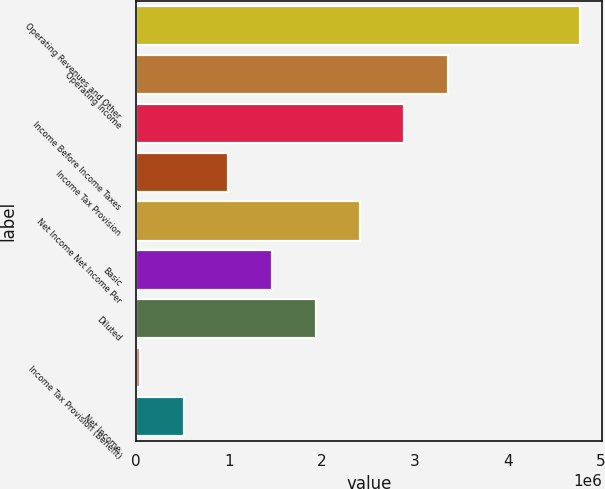Convert chart. <chart><loc_0><loc_0><loc_500><loc_500><bar_chart><fcel>Operating Revenues and Other<fcel>Operating Income<fcel>Income Before Income Taxes<fcel>Income Tax Provision<fcel>Net Income Net Income Per<fcel>Basic<fcel>Diluted<fcel>Income Tax Provision (Benefit)<fcel>Net Income<nl><fcel>4.78162e+06<fcel>3.36077e+06<fcel>2.88715e+06<fcel>992676<fcel>2.41353e+06<fcel>1.46629e+06<fcel>1.93991e+06<fcel>45439<fcel>519058<nl></chart> 